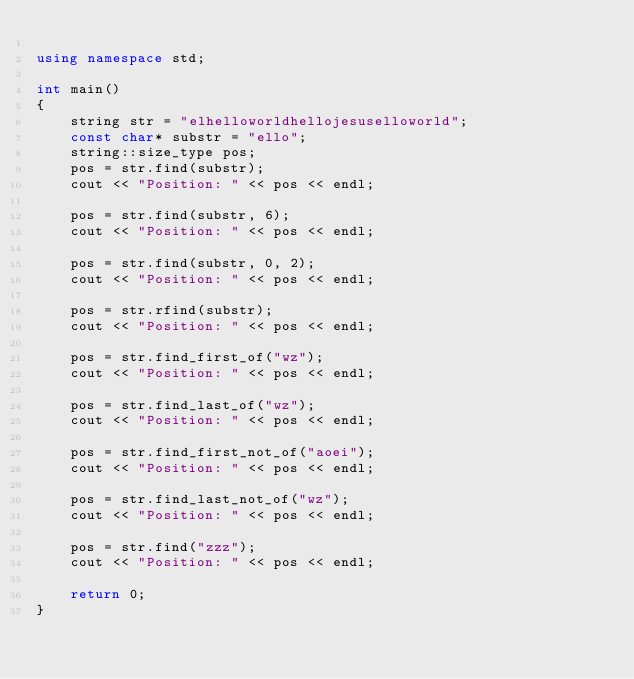<code> <loc_0><loc_0><loc_500><loc_500><_C++_>
using namespace std;

int main()
{
    string str = "elhelloworldhellojesuselloworld";
    const char* substr = "ello";
    string::size_type pos;
    pos = str.find(substr);
    cout << "Position: " << pos << endl;

    pos = str.find(substr, 6);
    cout << "Position: " << pos << endl;

    pos = str.find(substr, 0, 2);
    cout << "Position: " << pos << endl;

    pos = str.rfind(substr);
    cout << "Position: " << pos << endl;

    pos = str.find_first_of("wz");
    cout << "Position: " << pos << endl;

    pos = str.find_last_of("wz");
    cout << "Position: " << pos << endl;

    pos = str.find_first_not_of("aoei");
    cout << "Position: " << pos << endl;

    pos = str.find_last_not_of("wz");
    cout << "Position: " << pos << endl;

    pos = str.find("zzz");
    cout << "Position: " << pos << endl;

    return 0;
}</code> 